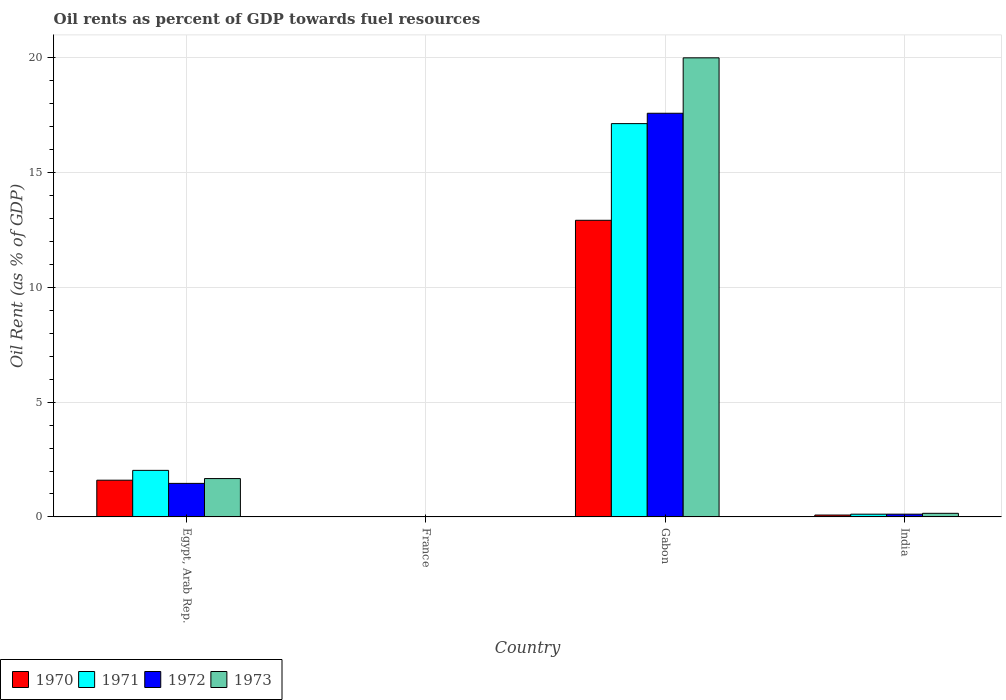How many bars are there on the 3rd tick from the left?
Make the answer very short. 4. What is the label of the 2nd group of bars from the left?
Give a very brief answer. France. In how many cases, is the number of bars for a given country not equal to the number of legend labels?
Your answer should be compact. 0. What is the oil rent in 1973 in Gabon?
Make the answer very short. 19.99. Across all countries, what is the maximum oil rent in 1971?
Make the answer very short. 17.13. Across all countries, what is the minimum oil rent in 1971?
Keep it short and to the point. 0.01. In which country was the oil rent in 1972 maximum?
Give a very brief answer. Gabon. In which country was the oil rent in 1971 minimum?
Make the answer very short. France. What is the total oil rent in 1970 in the graph?
Make the answer very short. 14.61. What is the difference between the oil rent in 1971 in Egypt, Arab Rep. and that in France?
Offer a terse response. 2.02. What is the difference between the oil rent in 1972 in Egypt, Arab Rep. and the oil rent in 1973 in Gabon?
Keep it short and to the point. -18.53. What is the average oil rent in 1972 per country?
Ensure brevity in your answer.  4.79. What is the difference between the oil rent of/in 1971 and oil rent of/in 1970 in India?
Provide a short and direct response. 0.04. What is the ratio of the oil rent in 1970 in Egypt, Arab Rep. to that in India?
Your answer should be compact. 19.39. Is the oil rent in 1970 in Egypt, Arab Rep. less than that in France?
Provide a short and direct response. No. Is the difference between the oil rent in 1971 in France and Gabon greater than the difference between the oil rent in 1970 in France and Gabon?
Give a very brief answer. No. What is the difference between the highest and the second highest oil rent in 1971?
Provide a short and direct response. -17.01. What is the difference between the highest and the lowest oil rent in 1972?
Give a very brief answer. 17.57. Is the sum of the oil rent in 1972 in Gabon and India greater than the maximum oil rent in 1971 across all countries?
Ensure brevity in your answer.  Yes. How many bars are there?
Keep it short and to the point. 16. What is the difference between two consecutive major ticks on the Y-axis?
Make the answer very short. 5. Are the values on the major ticks of Y-axis written in scientific E-notation?
Your answer should be compact. No. Does the graph contain any zero values?
Offer a very short reply. No. How are the legend labels stacked?
Your response must be concise. Horizontal. What is the title of the graph?
Make the answer very short. Oil rents as percent of GDP towards fuel resources. What is the label or title of the X-axis?
Offer a terse response. Country. What is the label or title of the Y-axis?
Make the answer very short. Oil Rent (as % of GDP). What is the Oil Rent (as % of GDP) in 1970 in Egypt, Arab Rep.?
Make the answer very short. 1.6. What is the Oil Rent (as % of GDP) of 1971 in Egypt, Arab Rep.?
Keep it short and to the point. 2.03. What is the Oil Rent (as % of GDP) of 1972 in Egypt, Arab Rep.?
Give a very brief answer. 1.46. What is the Oil Rent (as % of GDP) of 1973 in Egypt, Arab Rep.?
Provide a short and direct response. 1.67. What is the Oil Rent (as % of GDP) in 1970 in France?
Offer a very short reply. 0.01. What is the Oil Rent (as % of GDP) in 1971 in France?
Offer a terse response. 0.01. What is the Oil Rent (as % of GDP) in 1972 in France?
Your response must be concise. 0.01. What is the Oil Rent (as % of GDP) of 1973 in France?
Provide a short and direct response. 0.01. What is the Oil Rent (as % of GDP) in 1970 in Gabon?
Give a very brief answer. 12.92. What is the Oil Rent (as % of GDP) of 1971 in Gabon?
Your answer should be compact. 17.13. What is the Oil Rent (as % of GDP) of 1972 in Gabon?
Make the answer very short. 17.58. What is the Oil Rent (as % of GDP) in 1973 in Gabon?
Give a very brief answer. 19.99. What is the Oil Rent (as % of GDP) of 1970 in India?
Offer a very short reply. 0.08. What is the Oil Rent (as % of GDP) of 1971 in India?
Make the answer very short. 0.12. What is the Oil Rent (as % of GDP) of 1972 in India?
Offer a terse response. 0.12. What is the Oil Rent (as % of GDP) of 1973 in India?
Give a very brief answer. 0.16. Across all countries, what is the maximum Oil Rent (as % of GDP) in 1970?
Your answer should be very brief. 12.92. Across all countries, what is the maximum Oil Rent (as % of GDP) in 1971?
Your answer should be compact. 17.13. Across all countries, what is the maximum Oil Rent (as % of GDP) of 1972?
Provide a succinct answer. 17.58. Across all countries, what is the maximum Oil Rent (as % of GDP) of 1973?
Make the answer very short. 19.99. Across all countries, what is the minimum Oil Rent (as % of GDP) of 1970?
Offer a terse response. 0.01. Across all countries, what is the minimum Oil Rent (as % of GDP) in 1971?
Make the answer very short. 0.01. Across all countries, what is the minimum Oil Rent (as % of GDP) in 1972?
Make the answer very short. 0.01. Across all countries, what is the minimum Oil Rent (as % of GDP) of 1973?
Make the answer very short. 0.01. What is the total Oil Rent (as % of GDP) of 1970 in the graph?
Your answer should be compact. 14.61. What is the total Oil Rent (as % of GDP) of 1971 in the graph?
Provide a short and direct response. 19.29. What is the total Oil Rent (as % of GDP) in 1972 in the graph?
Give a very brief answer. 19.17. What is the total Oil Rent (as % of GDP) in 1973 in the graph?
Keep it short and to the point. 21.83. What is the difference between the Oil Rent (as % of GDP) in 1970 in Egypt, Arab Rep. and that in France?
Your response must be concise. 1.59. What is the difference between the Oil Rent (as % of GDP) in 1971 in Egypt, Arab Rep. and that in France?
Offer a terse response. 2.02. What is the difference between the Oil Rent (as % of GDP) in 1972 in Egypt, Arab Rep. and that in France?
Provide a succinct answer. 1.45. What is the difference between the Oil Rent (as % of GDP) in 1973 in Egypt, Arab Rep. and that in France?
Offer a terse response. 1.66. What is the difference between the Oil Rent (as % of GDP) of 1970 in Egypt, Arab Rep. and that in Gabon?
Your answer should be very brief. -11.32. What is the difference between the Oil Rent (as % of GDP) in 1971 in Egypt, Arab Rep. and that in Gabon?
Provide a succinct answer. -15.1. What is the difference between the Oil Rent (as % of GDP) of 1972 in Egypt, Arab Rep. and that in Gabon?
Provide a short and direct response. -16.12. What is the difference between the Oil Rent (as % of GDP) in 1973 in Egypt, Arab Rep. and that in Gabon?
Offer a terse response. -18.32. What is the difference between the Oil Rent (as % of GDP) in 1970 in Egypt, Arab Rep. and that in India?
Ensure brevity in your answer.  1.52. What is the difference between the Oil Rent (as % of GDP) in 1971 in Egypt, Arab Rep. and that in India?
Keep it short and to the point. 1.91. What is the difference between the Oil Rent (as % of GDP) of 1972 in Egypt, Arab Rep. and that in India?
Your answer should be very brief. 1.34. What is the difference between the Oil Rent (as % of GDP) of 1973 in Egypt, Arab Rep. and that in India?
Give a very brief answer. 1.51. What is the difference between the Oil Rent (as % of GDP) of 1970 in France and that in Gabon?
Offer a terse response. -12.91. What is the difference between the Oil Rent (as % of GDP) of 1971 in France and that in Gabon?
Ensure brevity in your answer.  -17.12. What is the difference between the Oil Rent (as % of GDP) of 1972 in France and that in Gabon?
Offer a very short reply. -17.57. What is the difference between the Oil Rent (as % of GDP) in 1973 in France and that in Gabon?
Your response must be concise. -19.98. What is the difference between the Oil Rent (as % of GDP) in 1970 in France and that in India?
Your answer should be compact. -0.07. What is the difference between the Oil Rent (as % of GDP) of 1971 in France and that in India?
Provide a short and direct response. -0.11. What is the difference between the Oil Rent (as % of GDP) in 1972 in France and that in India?
Your answer should be compact. -0.11. What is the difference between the Oil Rent (as % of GDP) of 1973 in France and that in India?
Your answer should be very brief. -0.15. What is the difference between the Oil Rent (as % of GDP) in 1970 in Gabon and that in India?
Your answer should be compact. 12.84. What is the difference between the Oil Rent (as % of GDP) of 1971 in Gabon and that in India?
Provide a short and direct response. 17.01. What is the difference between the Oil Rent (as % of GDP) in 1972 in Gabon and that in India?
Offer a very short reply. 17.46. What is the difference between the Oil Rent (as % of GDP) in 1973 in Gabon and that in India?
Make the answer very short. 19.84. What is the difference between the Oil Rent (as % of GDP) of 1970 in Egypt, Arab Rep. and the Oil Rent (as % of GDP) of 1971 in France?
Offer a terse response. 1.59. What is the difference between the Oil Rent (as % of GDP) in 1970 in Egypt, Arab Rep. and the Oil Rent (as % of GDP) in 1972 in France?
Your answer should be very brief. 1.59. What is the difference between the Oil Rent (as % of GDP) in 1970 in Egypt, Arab Rep. and the Oil Rent (as % of GDP) in 1973 in France?
Provide a succinct answer. 1.59. What is the difference between the Oil Rent (as % of GDP) of 1971 in Egypt, Arab Rep. and the Oil Rent (as % of GDP) of 1972 in France?
Your answer should be very brief. 2.02. What is the difference between the Oil Rent (as % of GDP) of 1971 in Egypt, Arab Rep. and the Oil Rent (as % of GDP) of 1973 in France?
Offer a terse response. 2.02. What is the difference between the Oil Rent (as % of GDP) of 1972 in Egypt, Arab Rep. and the Oil Rent (as % of GDP) of 1973 in France?
Make the answer very short. 1.45. What is the difference between the Oil Rent (as % of GDP) of 1970 in Egypt, Arab Rep. and the Oil Rent (as % of GDP) of 1971 in Gabon?
Provide a short and direct response. -15.53. What is the difference between the Oil Rent (as % of GDP) of 1970 in Egypt, Arab Rep. and the Oil Rent (as % of GDP) of 1972 in Gabon?
Provide a short and direct response. -15.98. What is the difference between the Oil Rent (as % of GDP) of 1970 in Egypt, Arab Rep. and the Oil Rent (as % of GDP) of 1973 in Gabon?
Provide a short and direct response. -18.39. What is the difference between the Oil Rent (as % of GDP) of 1971 in Egypt, Arab Rep. and the Oil Rent (as % of GDP) of 1972 in Gabon?
Provide a succinct answer. -15.55. What is the difference between the Oil Rent (as % of GDP) of 1971 in Egypt, Arab Rep. and the Oil Rent (as % of GDP) of 1973 in Gabon?
Make the answer very short. -17.97. What is the difference between the Oil Rent (as % of GDP) in 1972 in Egypt, Arab Rep. and the Oil Rent (as % of GDP) in 1973 in Gabon?
Keep it short and to the point. -18.53. What is the difference between the Oil Rent (as % of GDP) of 1970 in Egypt, Arab Rep. and the Oil Rent (as % of GDP) of 1971 in India?
Ensure brevity in your answer.  1.48. What is the difference between the Oil Rent (as % of GDP) in 1970 in Egypt, Arab Rep. and the Oil Rent (as % of GDP) in 1972 in India?
Ensure brevity in your answer.  1.48. What is the difference between the Oil Rent (as % of GDP) of 1970 in Egypt, Arab Rep. and the Oil Rent (as % of GDP) of 1973 in India?
Your answer should be very brief. 1.44. What is the difference between the Oil Rent (as % of GDP) of 1971 in Egypt, Arab Rep. and the Oil Rent (as % of GDP) of 1972 in India?
Give a very brief answer. 1.91. What is the difference between the Oil Rent (as % of GDP) in 1971 in Egypt, Arab Rep. and the Oil Rent (as % of GDP) in 1973 in India?
Offer a very short reply. 1.87. What is the difference between the Oil Rent (as % of GDP) in 1972 in Egypt, Arab Rep. and the Oil Rent (as % of GDP) in 1973 in India?
Keep it short and to the point. 1.3. What is the difference between the Oil Rent (as % of GDP) in 1970 in France and the Oil Rent (as % of GDP) in 1971 in Gabon?
Ensure brevity in your answer.  -17.12. What is the difference between the Oil Rent (as % of GDP) of 1970 in France and the Oil Rent (as % of GDP) of 1972 in Gabon?
Give a very brief answer. -17.57. What is the difference between the Oil Rent (as % of GDP) in 1970 in France and the Oil Rent (as % of GDP) in 1973 in Gabon?
Your response must be concise. -19.98. What is the difference between the Oil Rent (as % of GDP) in 1971 in France and the Oil Rent (as % of GDP) in 1972 in Gabon?
Make the answer very short. -17.57. What is the difference between the Oil Rent (as % of GDP) in 1971 in France and the Oil Rent (as % of GDP) in 1973 in Gabon?
Your answer should be very brief. -19.98. What is the difference between the Oil Rent (as % of GDP) in 1972 in France and the Oil Rent (as % of GDP) in 1973 in Gabon?
Keep it short and to the point. -19.99. What is the difference between the Oil Rent (as % of GDP) in 1970 in France and the Oil Rent (as % of GDP) in 1971 in India?
Keep it short and to the point. -0.11. What is the difference between the Oil Rent (as % of GDP) in 1970 in France and the Oil Rent (as % of GDP) in 1972 in India?
Provide a succinct answer. -0.11. What is the difference between the Oil Rent (as % of GDP) of 1970 in France and the Oil Rent (as % of GDP) of 1973 in India?
Provide a succinct answer. -0.15. What is the difference between the Oil Rent (as % of GDP) in 1971 in France and the Oil Rent (as % of GDP) in 1972 in India?
Give a very brief answer. -0.11. What is the difference between the Oil Rent (as % of GDP) of 1971 in France and the Oil Rent (as % of GDP) of 1973 in India?
Offer a very short reply. -0.14. What is the difference between the Oil Rent (as % of GDP) of 1972 in France and the Oil Rent (as % of GDP) of 1973 in India?
Provide a succinct answer. -0.15. What is the difference between the Oil Rent (as % of GDP) of 1970 in Gabon and the Oil Rent (as % of GDP) of 1971 in India?
Ensure brevity in your answer.  12.8. What is the difference between the Oil Rent (as % of GDP) in 1970 in Gabon and the Oil Rent (as % of GDP) in 1972 in India?
Your answer should be compact. 12.8. What is the difference between the Oil Rent (as % of GDP) of 1970 in Gabon and the Oil Rent (as % of GDP) of 1973 in India?
Offer a terse response. 12.76. What is the difference between the Oil Rent (as % of GDP) of 1971 in Gabon and the Oil Rent (as % of GDP) of 1972 in India?
Offer a very short reply. 17.01. What is the difference between the Oil Rent (as % of GDP) in 1971 in Gabon and the Oil Rent (as % of GDP) in 1973 in India?
Keep it short and to the point. 16.97. What is the difference between the Oil Rent (as % of GDP) in 1972 in Gabon and the Oil Rent (as % of GDP) in 1973 in India?
Provide a short and direct response. 17.42. What is the average Oil Rent (as % of GDP) of 1970 per country?
Provide a short and direct response. 3.65. What is the average Oil Rent (as % of GDP) in 1971 per country?
Give a very brief answer. 4.82. What is the average Oil Rent (as % of GDP) in 1972 per country?
Make the answer very short. 4.79. What is the average Oil Rent (as % of GDP) in 1973 per country?
Provide a short and direct response. 5.46. What is the difference between the Oil Rent (as % of GDP) of 1970 and Oil Rent (as % of GDP) of 1971 in Egypt, Arab Rep.?
Ensure brevity in your answer.  -0.43. What is the difference between the Oil Rent (as % of GDP) of 1970 and Oil Rent (as % of GDP) of 1972 in Egypt, Arab Rep.?
Offer a terse response. 0.14. What is the difference between the Oil Rent (as % of GDP) of 1970 and Oil Rent (as % of GDP) of 1973 in Egypt, Arab Rep.?
Your response must be concise. -0.07. What is the difference between the Oil Rent (as % of GDP) in 1971 and Oil Rent (as % of GDP) in 1972 in Egypt, Arab Rep.?
Keep it short and to the point. 0.57. What is the difference between the Oil Rent (as % of GDP) in 1971 and Oil Rent (as % of GDP) in 1973 in Egypt, Arab Rep.?
Your response must be concise. 0.36. What is the difference between the Oil Rent (as % of GDP) in 1972 and Oil Rent (as % of GDP) in 1973 in Egypt, Arab Rep.?
Your response must be concise. -0.21. What is the difference between the Oil Rent (as % of GDP) of 1970 and Oil Rent (as % of GDP) of 1971 in France?
Keep it short and to the point. -0. What is the difference between the Oil Rent (as % of GDP) of 1970 and Oil Rent (as % of GDP) of 1972 in France?
Provide a short and direct response. 0. What is the difference between the Oil Rent (as % of GDP) of 1970 and Oil Rent (as % of GDP) of 1973 in France?
Give a very brief answer. 0. What is the difference between the Oil Rent (as % of GDP) of 1971 and Oil Rent (as % of GDP) of 1972 in France?
Make the answer very short. 0. What is the difference between the Oil Rent (as % of GDP) of 1971 and Oil Rent (as % of GDP) of 1973 in France?
Keep it short and to the point. 0. What is the difference between the Oil Rent (as % of GDP) of 1972 and Oil Rent (as % of GDP) of 1973 in France?
Give a very brief answer. -0. What is the difference between the Oil Rent (as % of GDP) in 1970 and Oil Rent (as % of GDP) in 1971 in Gabon?
Your answer should be compact. -4.21. What is the difference between the Oil Rent (as % of GDP) of 1970 and Oil Rent (as % of GDP) of 1972 in Gabon?
Keep it short and to the point. -4.66. What is the difference between the Oil Rent (as % of GDP) in 1970 and Oil Rent (as % of GDP) in 1973 in Gabon?
Give a very brief answer. -7.08. What is the difference between the Oil Rent (as % of GDP) of 1971 and Oil Rent (as % of GDP) of 1972 in Gabon?
Your answer should be very brief. -0.45. What is the difference between the Oil Rent (as % of GDP) in 1971 and Oil Rent (as % of GDP) in 1973 in Gabon?
Make the answer very short. -2.87. What is the difference between the Oil Rent (as % of GDP) in 1972 and Oil Rent (as % of GDP) in 1973 in Gabon?
Offer a terse response. -2.41. What is the difference between the Oil Rent (as % of GDP) in 1970 and Oil Rent (as % of GDP) in 1971 in India?
Provide a succinct answer. -0.04. What is the difference between the Oil Rent (as % of GDP) of 1970 and Oil Rent (as % of GDP) of 1972 in India?
Offer a very short reply. -0.04. What is the difference between the Oil Rent (as % of GDP) of 1970 and Oil Rent (as % of GDP) of 1973 in India?
Offer a very short reply. -0.07. What is the difference between the Oil Rent (as % of GDP) of 1971 and Oil Rent (as % of GDP) of 1972 in India?
Offer a very short reply. -0. What is the difference between the Oil Rent (as % of GDP) of 1971 and Oil Rent (as % of GDP) of 1973 in India?
Your answer should be very brief. -0.04. What is the difference between the Oil Rent (as % of GDP) in 1972 and Oil Rent (as % of GDP) in 1973 in India?
Provide a short and direct response. -0.04. What is the ratio of the Oil Rent (as % of GDP) of 1970 in Egypt, Arab Rep. to that in France?
Ensure brevity in your answer.  139.1. What is the ratio of the Oil Rent (as % of GDP) in 1971 in Egypt, Arab Rep. to that in France?
Your answer should be compact. 164.4. What is the ratio of the Oil Rent (as % of GDP) in 1972 in Egypt, Arab Rep. to that in France?
Provide a succinct answer. 171.93. What is the ratio of the Oil Rent (as % of GDP) in 1973 in Egypt, Arab Rep. to that in France?
Provide a short and direct response. 189.03. What is the ratio of the Oil Rent (as % of GDP) of 1970 in Egypt, Arab Rep. to that in Gabon?
Give a very brief answer. 0.12. What is the ratio of the Oil Rent (as % of GDP) in 1971 in Egypt, Arab Rep. to that in Gabon?
Offer a very short reply. 0.12. What is the ratio of the Oil Rent (as % of GDP) in 1972 in Egypt, Arab Rep. to that in Gabon?
Offer a terse response. 0.08. What is the ratio of the Oil Rent (as % of GDP) in 1973 in Egypt, Arab Rep. to that in Gabon?
Your answer should be very brief. 0.08. What is the ratio of the Oil Rent (as % of GDP) of 1970 in Egypt, Arab Rep. to that in India?
Your answer should be compact. 19.39. What is the ratio of the Oil Rent (as % of GDP) of 1971 in Egypt, Arab Rep. to that in India?
Your answer should be compact. 16.93. What is the ratio of the Oil Rent (as % of GDP) of 1972 in Egypt, Arab Rep. to that in India?
Ensure brevity in your answer.  12.16. What is the ratio of the Oil Rent (as % of GDP) in 1973 in Egypt, Arab Rep. to that in India?
Your response must be concise. 10.63. What is the ratio of the Oil Rent (as % of GDP) of 1970 in France to that in Gabon?
Your response must be concise. 0. What is the ratio of the Oil Rent (as % of GDP) of 1971 in France to that in Gabon?
Provide a succinct answer. 0. What is the ratio of the Oil Rent (as % of GDP) in 1973 in France to that in Gabon?
Your answer should be very brief. 0. What is the ratio of the Oil Rent (as % of GDP) in 1970 in France to that in India?
Your answer should be compact. 0.14. What is the ratio of the Oil Rent (as % of GDP) of 1971 in France to that in India?
Make the answer very short. 0.1. What is the ratio of the Oil Rent (as % of GDP) of 1972 in France to that in India?
Keep it short and to the point. 0.07. What is the ratio of the Oil Rent (as % of GDP) of 1973 in France to that in India?
Your answer should be compact. 0.06. What is the ratio of the Oil Rent (as % of GDP) in 1970 in Gabon to that in India?
Provide a short and direct response. 156.62. What is the ratio of the Oil Rent (as % of GDP) of 1971 in Gabon to that in India?
Your answer should be very brief. 142.99. What is the ratio of the Oil Rent (as % of GDP) in 1972 in Gabon to that in India?
Your answer should be very brief. 146.29. What is the ratio of the Oil Rent (as % of GDP) of 1973 in Gabon to that in India?
Make the answer very short. 127.16. What is the difference between the highest and the second highest Oil Rent (as % of GDP) of 1970?
Give a very brief answer. 11.32. What is the difference between the highest and the second highest Oil Rent (as % of GDP) of 1971?
Offer a terse response. 15.1. What is the difference between the highest and the second highest Oil Rent (as % of GDP) in 1972?
Provide a succinct answer. 16.12. What is the difference between the highest and the second highest Oil Rent (as % of GDP) in 1973?
Your answer should be compact. 18.32. What is the difference between the highest and the lowest Oil Rent (as % of GDP) in 1970?
Ensure brevity in your answer.  12.91. What is the difference between the highest and the lowest Oil Rent (as % of GDP) of 1971?
Ensure brevity in your answer.  17.12. What is the difference between the highest and the lowest Oil Rent (as % of GDP) of 1972?
Give a very brief answer. 17.57. What is the difference between the highest and the lowest Oil Rent (as % of GDP) in 1973?
Give a very brief answer. 19.98. 